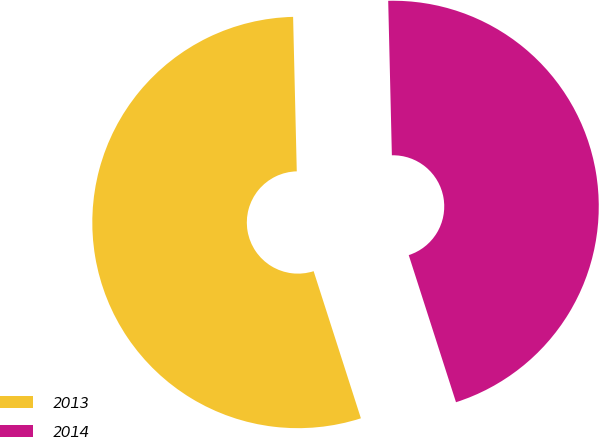Convert chart. <chart><loc_0><loc_0><loc_500><loc_500><pie_chart><fcel>2013<fcel>2014<nl><fcel>54.57%<fcel>45.43%<nl></chart> 